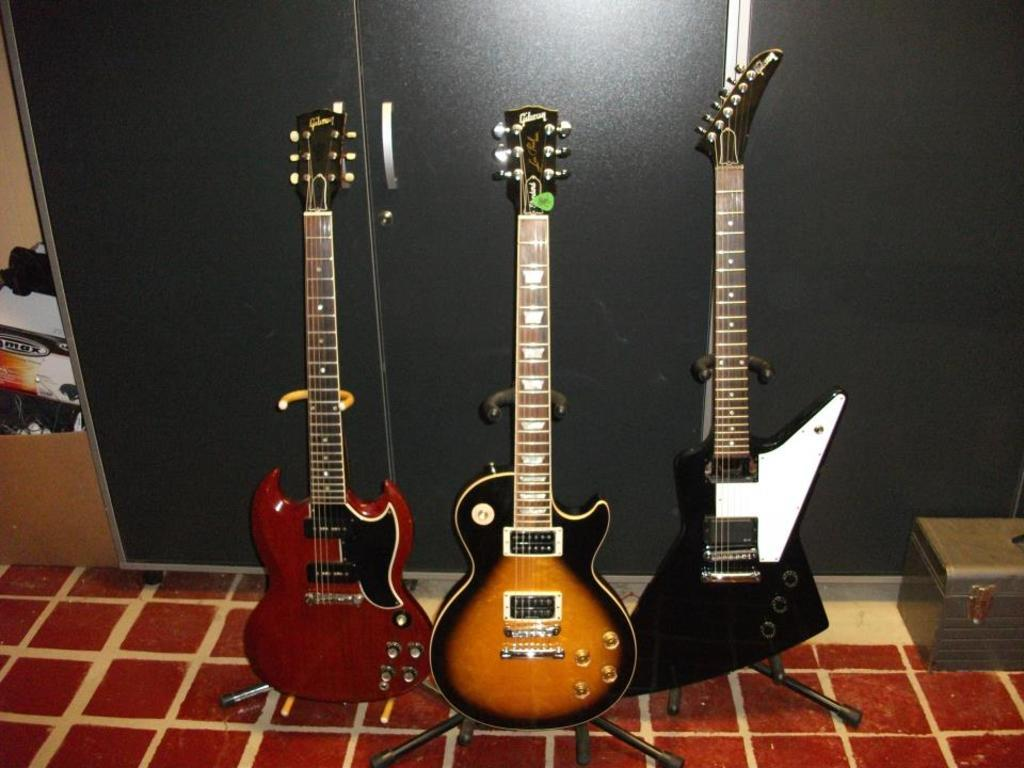What is the main subject of the image? The main subject of the image is three guitars in the center of the image. Are there any other objects or items visible in the image? Yes, there is a box on the right side of the image and a grey color cupboard in the background of the image. How many jewels can be seen on the guitars in the image? There are no jewels present on the guitars in the image. What type of mice can be seen interacting with the guitars in the image? There are no mice present in the image, and the guitars are not interacting with any creatures. 